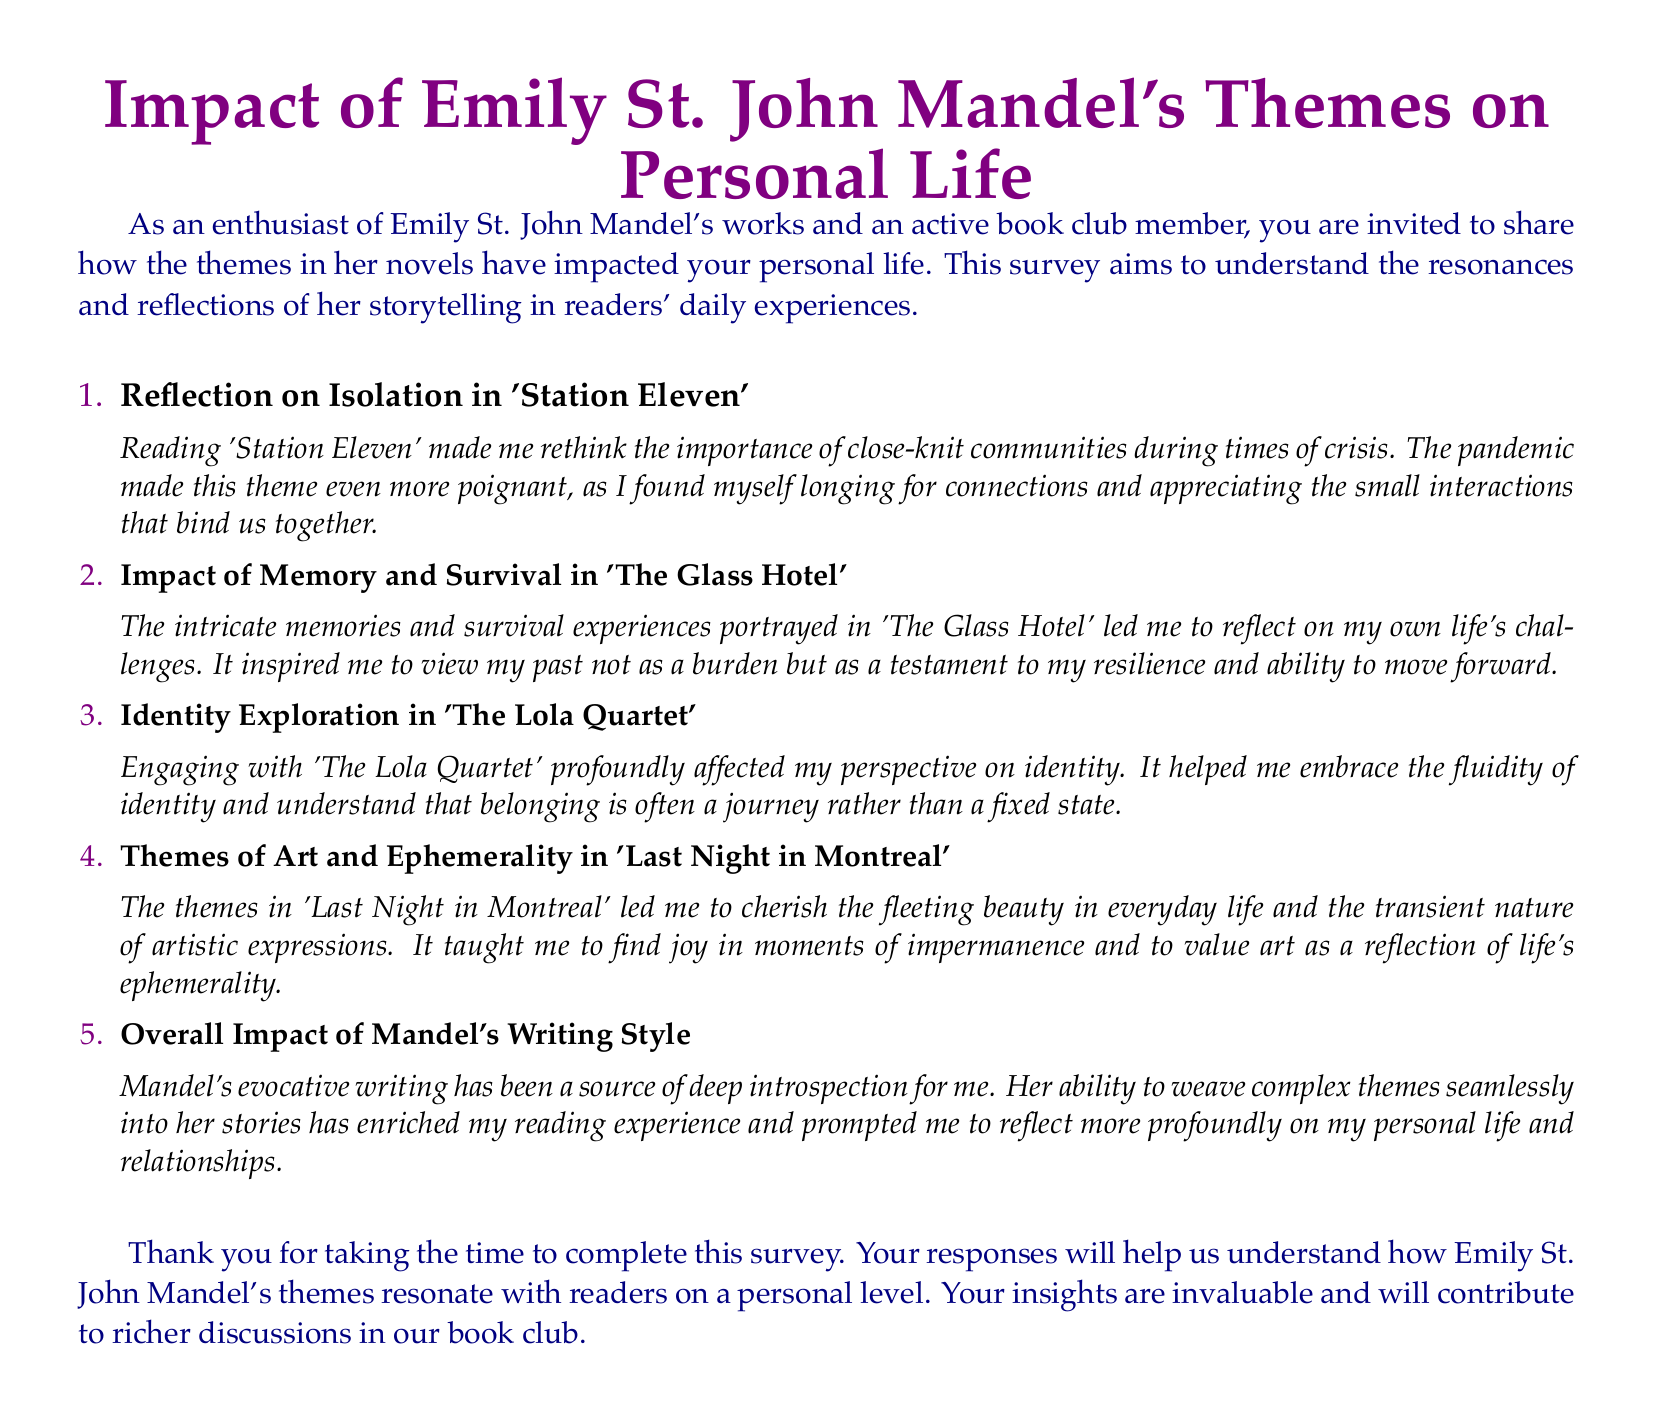What is the title of the survey? The title of the survey is presented in a large font at the beginning of the document.
Answer: Impact of Emily St. John Mandel's Themes on Personal Life What novel is associated with the theme of isolation? This information is found in the first reflection, which specifies the novel related to isolation.
Answer: Station Eleven Which theme does 'The Glass Hotel' explore? The theme explored in 'The Glass Hotel' is specified in the second reflection.
Answer: Memory and Survival What is a key theme in 'Last Night in Montreal'? The theme from 'Last Night in Montreal' is outlined in the fourth reflection section of the document.
Answer: Art and Ephemerality How has Mandel's writing affected the respondent? The overall impact of Mandel's writing is discussed at the end of the reflection list.
Answer: Deep introspection What coloring is used for the headings in the document? The document specifies the color used for headings such as the survey title and question labels.
Answer: Purple What type of document is this? This document is structured to gather personal reflections and experiences regarding a specific author's themes.
Answer: Survey form How many reflections are provided in the survey? The document contains a specific number of reflections listed in the enumerated format.
Answer: Five 